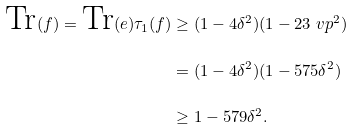Convert formula to latex. <formula><loc_0><loc_0><loc_500><loc_500>\text {Tr} ( f ) = \text {Tr} ( e ) \tau _ { 1 } ( f ) & \geq ( 1 - 4 \delta ^ { 2 } ) ( 1 - 2 3 \ v p ^ { 2 } ) \\ & = ( 1 - 4 \delta ^ { 2 } ) ( 1 - 5 7 5 \delta ^ { 2 } ) \\ & \geq 1 - 5 7 9 \delta ^ { 2 } .</formula> 